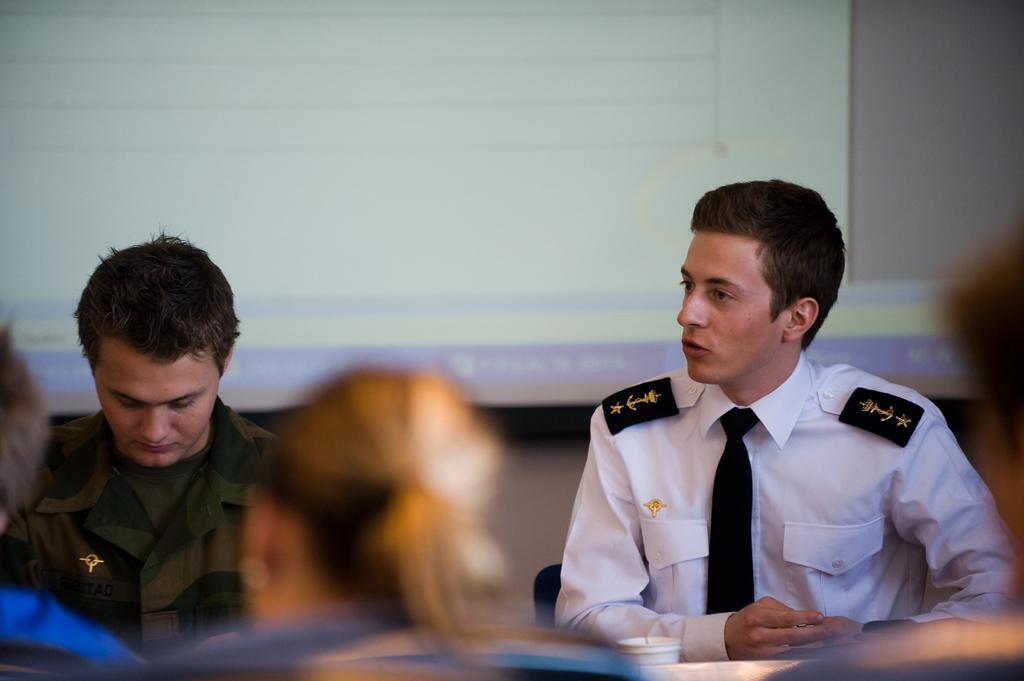How would you summarize this image in a sentence or two? The person wearing white dress is sitting in the right corner and there is another person sitting beside him and there are few other persons sitting in front of them and there is a projector which displayed a picture on it in the background. 